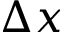<formula> <loc_0><loc_0><loc_500><loc_500>\Delta x</formula> 